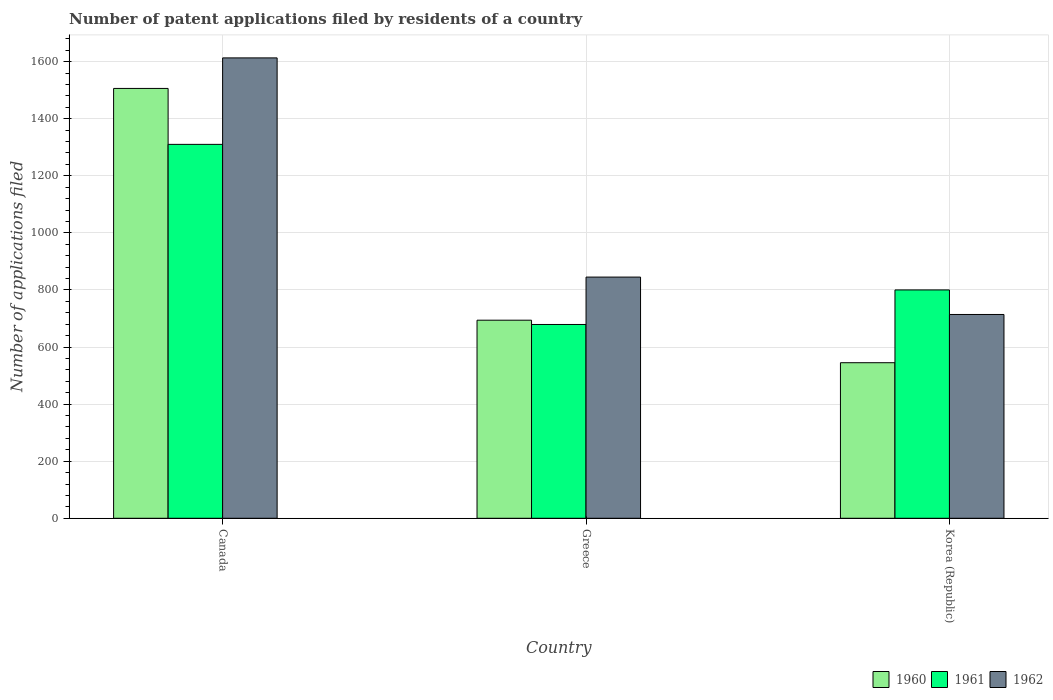How many different coloured bars are there?
Provide a succinct answer. 3. Are the number of bars per tick equal to the number of legend labels?
Your answer should be very brief. Yes. Are the number of bars on each tick of the X-axis equal?
Offer a very short reply. Yes. What is the label of the 2nd group of bars from the left?
Provide a succinct answer. Greece. In how many cases, is the number of bars for a given country not equal to the number of legend labels?
Keep it short and to the point. 0. What is the number of applications filed in 1960 in Greece?
Offer a very short reply. 694. Across all countries, what is the maximum number of applications filed in 1962?
Offer a very short reply. 1613. Across all countries, what is the minimum number of applications filed in 1960?
Give a very brief answer. 545. In which country was the number of applications filed in 1962 minimum?
Your answer should be very brief. Korea (Republic). What is the total number of applications filed in 1961 in the graph?
Offer a very short reply. 2789. What is the difference between the number of applications filed in 1962 in Canada and that in Greece?
Your answer should be compact. 768. What is the difference between the number of applications filed in 1960 in Canada and the number of applications filed in 1961 in Korea (Republic)?
Offer a terse response. 706. What is the average number of applications filed in 1961 per country?
Give a very brief answer. 929.67. What is the difference between the number of applications filed of/in 1961 and number of applications filed of/in 1960 in Canada?
Your response must be concise. -196. What is the ratio of the number of applications filed in 1962 in Canada to that in Greece?
Your answer should be very brief. 1.91. Is the difference between the number of applications filed in 1961 in Canada and Korea (Republic) greater than the difference between the number of applications filed in 1960 in Canada and Korea (Republic)?
Your answer should be very brief. No. What is the difference between the highest and the second highest number of applications filed in 1960?
Your response must be concise. -961. What is the difference between the highest and the lowest number of applications filed in 1962?
Keep it short and to the point. 899. In how many countries, is the number of applications filed in 1962 greater than the average number of applications filed in 1962 taken over all countries?
Your answer should be compact. 1. What does the 1st bar from the left in Greece represents?
Make the answer very short. 1960. What does the 2nd bar from the right in Canada represents?
Ensure brevity in your answer.  1961. Are all the bars in the graph horizontal?
Your answer should be compact. No. What is the difference between two consecutive major ticks on the Y-axis?
Your answer should be compact. 200. Does the graph contain any zero values?
Give a very brief answer. No. Where does the legend appear in the graph?
Give a very brief answer. Bottom right. How many legend labels are there?
Offer a very short reply. 3. What is the title of the graph?
Your response must be concise. Number of patent applications filed by residents of a country. Does "1993" appear as one of the legend labels in the graph?
Provide a succinct answer. No. What is the label or title of the Y-axis?
Offer a terse response. Number of applications filed. What is the Number of applications filed of 1960 in Canada?
Your response must be concise. 1506. What is the Number of applications filed of 1961 in Canada?
Offer a terse response. 1310. What is the Number of applications filed of 1962 in Canada?
Offer a terse response. 1613. What is the Number of applications filed of 1960 in Greece?
Your response must be concise. 694. What is the Number of applications filed of 1961 in Greece?
Your answer should be very brief. 679. What is the Number of applications filed of 1962 in Greece?
Offer a very short reply. 845. What is the Number of applications filed of 1960 in Korea (Republic)?
Keep it short and to the point. 545. What is the Number of applications filed of 1961 in Korea (Republic)?
Provide a succinct answer. 800. What is the Number of applications filed in 1962 in Korea (Republic)?
Ensure brevity in your answer.  714. Across all countries, what is the maximum Number of applications filed in 1960?
Give a very brief answer. 1506. Across all countries, what is the maximum Number of applications filed in 1961?
Your response must be concise. 1310. Across all countries, what is the maximum Number of applications filed in 1962?
Give a very brief answer. 1613. Across all countries, what is the minimum Number of applications filed in 1960?
Provide a succinct answer. 545. Across all countries, what is the minimum Number of applications filed in 1961?
Offer a terse response. 679. Across all countries, what is the minimum Number of applications filed in 1962?
Provide a succinct answer. 714. What is the total Number of applications filed of 1960 in the graph?
Ensure brevity in your answer.  2745. What is the total Number of applications filed of 1961 in the graph?
Give a very brief answer. 2789. What is the total Number of applications filed in 1962 in the graph?
Your response must be concise. 3172. What is the difference between the Number of applications filed of 1960 in Canada and that in Greece?
Ensure brevity in your answer.  812. What is the difference between the Number of applications filed in 1961 in Canada and that in Greece?
Ensure brevity in your answer.  631. What is the difference between the Number of applications filed of 1962 in Canada and that in Greece?
Keep it short and to the point. 768. What is the difference between the Number of applications filed in 1960 in Canada and that in Korea (Republic)?
Your response must be concise. 961. What is the difference between the Number of applications filed in 1961 in Canada and that in Korea (Republic)?
Ensure brevity in your answer.  510. What is the difference between the Number of applications filed in 1962 in Canada and that in Korea (Republic)?
Ensure brevity in your answer.  899. What is the difference between the Number of applications filed of 1960 in Greece and that in Korea (Republic)?
Make the answer very short. 149. What is the difference between the Number of applications filed of 1961 in Greece and that in Korea (Republic)?
Your response must be concise. -121. What is the difference between the Number of applications filed of 1962 in Greece and that in Korea (Republic)?
Your answer should be very brief. 131. What is the difference between the Number of applications filed in 1960 in Canada and the Number of applications filed in 1961 in Greece?
Provide a succinct answer. 827. What is the difference between the Number of applications filed of 1960 in Canada and the Number of applications filed of 1962 in Greece?
Your answer should be very brief. 661. What is the difference between the Number of applications filed of 1961 in Canada and the Number of applications filed of 1962 in Greece?
Provide a succinct answer. 465. What is the difference between the Number of applications filed in 1960 in Canada and the Number of applications filed in 1961 in Korea (Republic)?
Give a very brief answer. 706. What is the difference between the Number of applications filed in 1960 in Canada and the Number of applications filed in 1962 in Korea (Republic)?
Offer a terse response. 792. What is the difference between the Number of applications filed in 1961 in Canada and the Number of applications filed in 1962 in Korea (Republic)?
Make the answer very short. 596. What is the difference between the Number of applications filed in 1960 in Greece and the Number of applications filed in 1961 in Korea (Republic)?
Offer a terse response. -106. What is the difference between the Number of applications filed in 1960 in Greece and the Number of applications filed in 1962 in Korea (Republic)?
Offer a terse response. -20. What is the difference between the Number of applications filed in 1961 in Greece and the Number of applications filed in 1962 in Korea (Republic)?
Give a very brief answer. -35. What is the average Number of applications filed of 1960 per country?
Provide a short and direct response. 915. What is the average Number of applications filed of 1961 per country?
Provide a short and direct response. 929.67. What is the average Number of applications filed in 1962 per country?
Ensure brevity in your answer.  1057.33. What is the difference between the Number of applications filed in 1960 and Number of applications filed in 1961 in Canada?
Provide a short and direct response. 196. What is the difference between the Number of applications filed of 1960 and Number of applications filed of 1962 in Canada?
Your answer should be compact. -107. What is the difference between the Number of applications filed of 1961 and Number of applications filed of 1962 in Canada?
Offer a terse response. -303. What is the difference between the Number of applications filed of 1960 and Number of applications filed of 1962 in Greece?
Keep it short and to the point. -151. What is the difference between the Number of applications filed in 1961 and Number of applications filed in 1962 in Greece?
Provide a short and direct response. -166. What is the difference between the Number of applications filed in 1960 and Number of applications filed in 1961 in Korea (Republic)?
Your response must be concise. -255. What is the difference between the Number of applications filed in 1960 and Number of applications filed in 1962 in Korea (Republic)?
Keep it short and to the point. -169. What is the difference between the Number of applications filed of 1961 and Number of applications filed of 1962 in Korea (Republic)?
Offer a very short reply. 86. What is the ratio of the Number of applications filed of 1960 in Canada to that in Greece?
Your answer should be compact. 2.17. What is the ratio of the Number of applications filed of 1961 in Canada to that in Greece?
Keep it short and to the point. 1.93. What is the ratio of the Number of applications filed of 1962 in Canada to that in Greece?
Make the answer very short. 1.91. What is the ratio of the Number of applications filed in 1960 in Canada to that in Korea (Republic)?
Offer a terse response. 2.76. What is the ratio of the Number of applications filed in 1961 in Canada to that in Korea (Republic)?
Offer a terse response. 1.64. What is the ratio of the Number of applications filed of 1962 in Canada to that in Korea (Republic)?
Your answer should be very brief. 2.26. What is the ratio of the Number of applications filed of 1960 in Greece to that in Korea (Republic)?
Provide a short and direct response. 1.27. What is the ratio of the Number of applications filed of 1961 in Greece to that in Korea (Republic)?
Make the answer very short. 0.85. What is the ratio of the Number of applications filed in 1962 in Greece to that in Korea (Republic)?
Your response must be concise. 1.18. What is the difference between the highest and the second highest Number of applications filed of 1960?
Provide a short and direct response. 812. What is the difference between the highest and the second highest Number of applications filed in 1961?
Offer a terse response. 510. What is the difference between the highest and the second highest Number of applications filed of 1962?
Your response must be concise. 768. What is the difference between the highest and the lowest Number of applications filed in 1960?
Your response must be concise. 961. What is the difference between the highest and the lowest Number of applications filed in 1961?
Give a very brief answer. 631. What is the difference between the highest and the lowest Number of applications filed of 1962?
Keep it short and to the point. 899. 